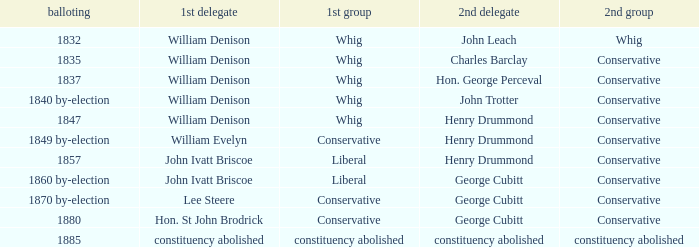Which party with an 1835 election has 1st member William Denison? Conservative. 